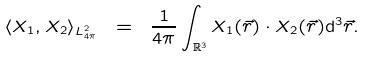Convert formula to latex. <formula><loc_0><loc_0><loc_500><loc_500>\langle X _ { 1 } , X _ { 2 } \rangle _ { L ^ { 2 } _ { 4 \pi } } \ = \ \frac { 1 } { 4 \pi } \int _ { \mathbb { R } ^ { 3 } } X _ { 1 } ( \vec { r } ) \cdot X _ { 2 } ( \vec { r } ) \mathrm d ^ { 3 } \vec { r } .</formula> 